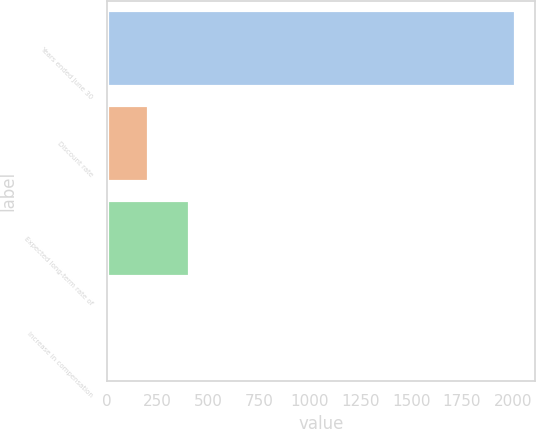Convert chart. <chart><loc_0><loc_0><loc_500><loc_500><bar_chart><fcel>Years ended June 30<fcel>Discount rate<fcel>Expected long-term rate of<fcel>Increase in compensation<nl><fcel>2010<fcel>205.95<fcel>406.4<fcel>5.5<nl></chart> 